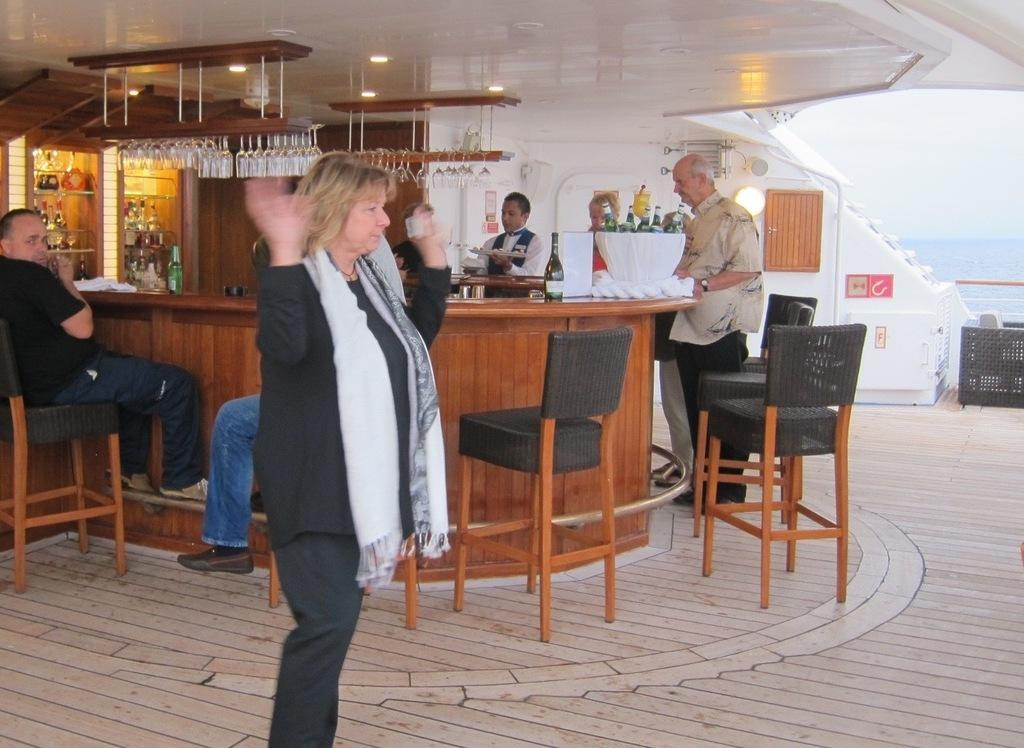What is present in the image that serves as a background or boundary? There is a wall in the image. What are the people in the image doing? The people in the image are standing and sitting. What type of furniture is visible in the image? There are chairs in the image. What is on the table in the image? There are glasses on the table. Can you describe the journey the fairies take in the image? There are no fairies present in the image, so it is not possible to describe a journey they might take. 